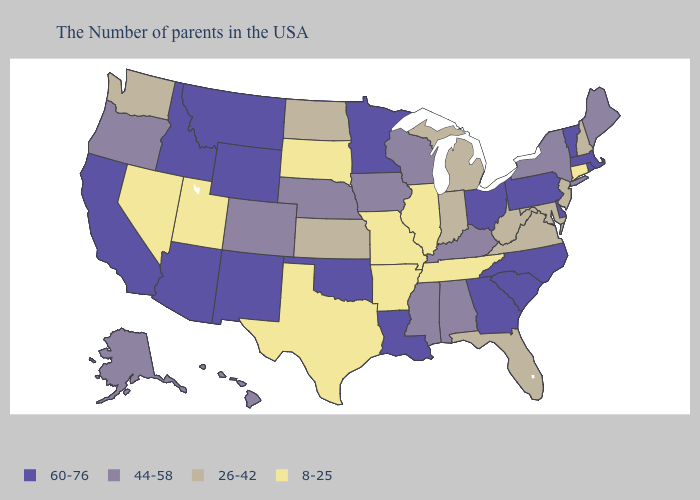Does Tennessee have a higher value than New Mexico?
Concise answer only. No. Does Connecticut have the lowest value in the Northeast?
Keep it brief. Yes. Is the legend a continuous bar?
Quick response, please. No. What is the value of Missouri?
Quick response, please. 8-25. What is the value of Wyoming?
Be succinct. 60-76. What is the value of Wisconsin?
Concise answer only. 44-58. Does Illinois have the same value as Iowa?
Give a very brief answer. No. Does Tennessee have a lower value than Connecticut?
Keep it brief. No. Name the states that have a value in the range 8-25?
Write a very short answer. Connecticut, Tennessee, Illinois, Missouri, Arkansas, Texas, South Dakota, Utah, Nevada. Which states have the highest value in the USA?
Keep it brief. Massachusetts, Rhode Island, Vermont, Delaware, Pennsylvania, North Carolina, South Carolina, Ohio, Georgia, Louisiana, Minnesota, Oklahoma, Wyoming, New Mexico, Montana, Arizona, Idaho, California. Name the states that have a value in the range 8-25?
Be succinct. Connecticut, Tennessee, Illinois, Missouri, Arkansas, Texas, South Dakota, Utah, Nevada. What is the lowest value in states that border Tennessee?
Be succinct. 8-25. How many symbols are there in the legend?
Answer briefly. 4. Does Minnesota have the highest value in the USA?
Quick response, please. Yes. Name the states that have a value in the range 8-25?
Concise answer only. Connecticut, Tennessee, Illinois, Missouri, Arkansas, Texas, South Dakota, Utah, Nevada. 